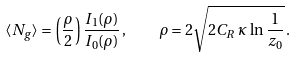<formula> <loc_0><loc_0><loc_500><loc_500>\langle N _ { g } \rangle = \left ( \frac { \rho } { 2 } \right ) \frac { I _ { 1 } ( \rho ) } { I _ { 0 } ( \rho ) } \, , \quad \rho = 2 \sqrt { 2 C _ { R } \, \kappa \, \ln \frac { 1 } { z _ { 0 } } } \, .</formula> 